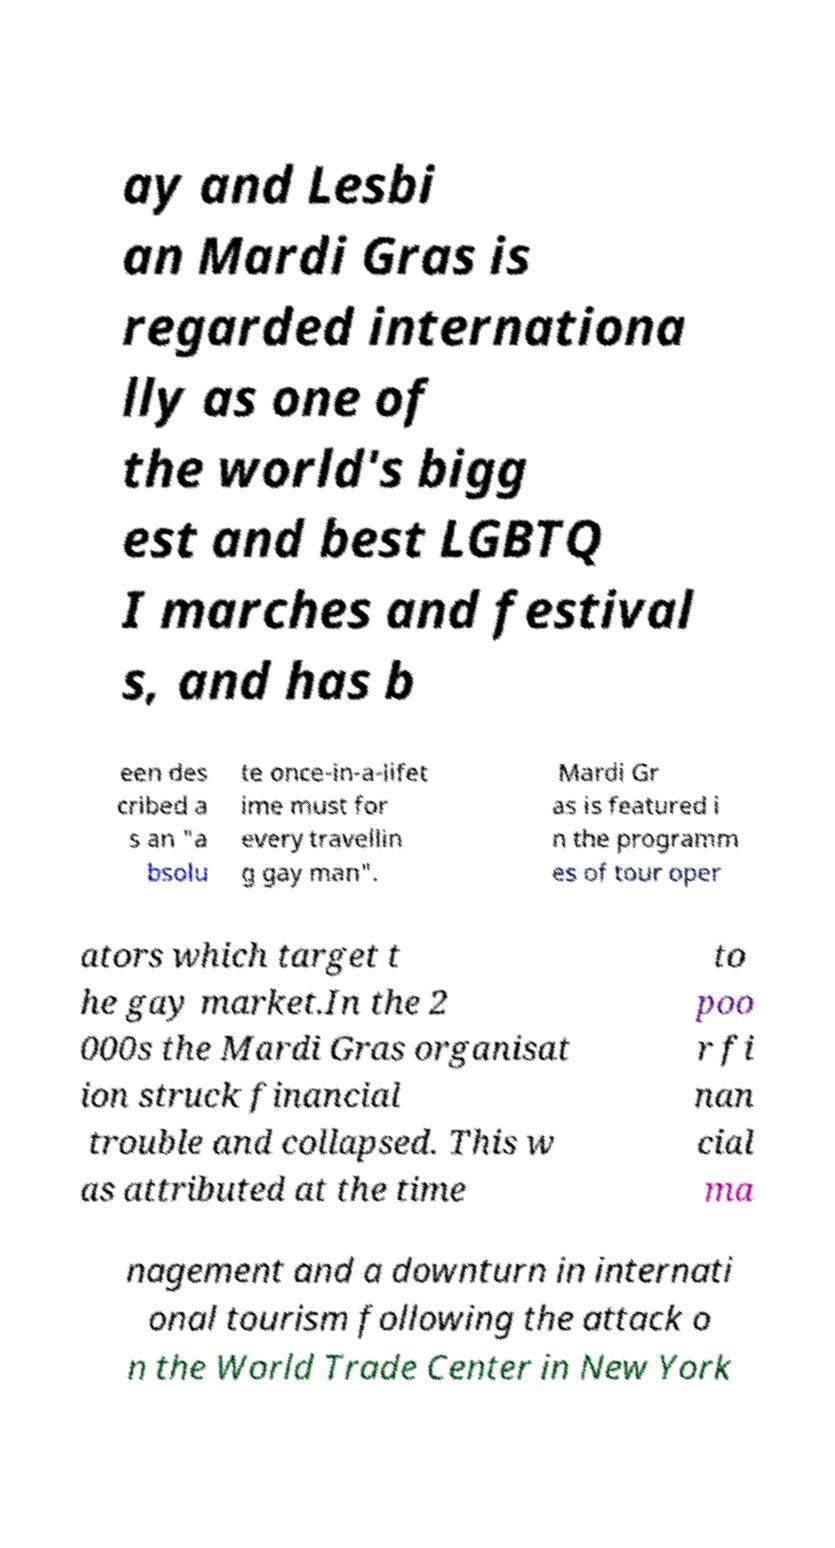Please read and relay the text visible in this image. What does it say? ay and Lesbi an Mardi Gras is regarded internationa lly as one of the world's bigg est and best LGBTQ I marches and festival s, and has b een des cribed a s an "a bsolu te once-in-a-lifet ime must for every travellin g gay man". Mardi Gr as is featured i n the programm es of tour oper ators which target t he gay market.In the 2 000s the Mardi Gras organisat ion struck financial trouble and collapsed. This w as attributed at the time to poo r fi nan cial ma nagement and a downturn in internati onal tourism following the attack o n the World Trade Center in New York 